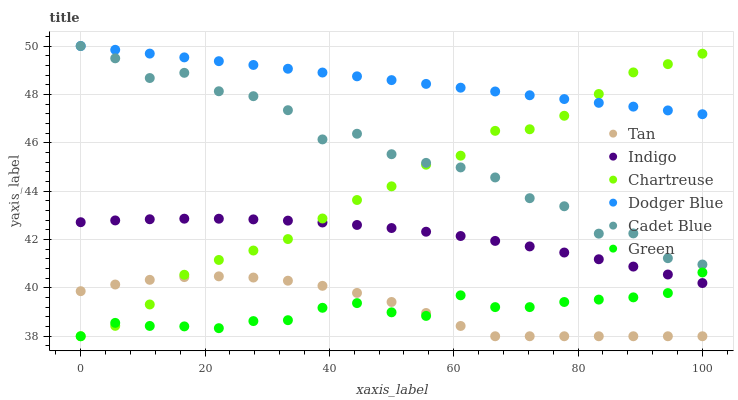Does Green have the minimum area under the curve?
Answer yes or no. Yes. Does Dodger Blue have the maximum area under the curve?
Answer yes or no. Yes. Does Indigo have the minimum area under the curve?
Answer yes or no. No. Does Indigo have the maximum area under the curve?
Answer yes or no. No. Is Dodger Blue the smoothest?
Answer yes or no. Yes. Is Cadet Blue the roughest?
Answer yes or no. Yes. Is Indigo the smoothest?
Answer yes or no. No. Is Indigo the roughest?
Answer yes or no. No. Does Chartreuse have the lowest value?
Answer yes or no. Yes. Does Indigo have the lowest value?
Answer yes or no. No. Does Dodger Blue have the highest value?
Answer yes or no. Yes. Does Indigo have the highest value?
Answer yes or no. No. Is Indigo less than Cadet Blue?
Answer yes or no. Yes. Is Cadet Blue greater than Tan?
Answer yes or no. Yes. Does Chartreuse intersect Green?
Answer yes or no. Yes. Is Chartreuse less than Green?
Answer yes or no. No. Is Chartreuse greater than Green?
Answer yes or no. No. Does Indigo intersect Cadet Blue?
Answer yes or no. No. 